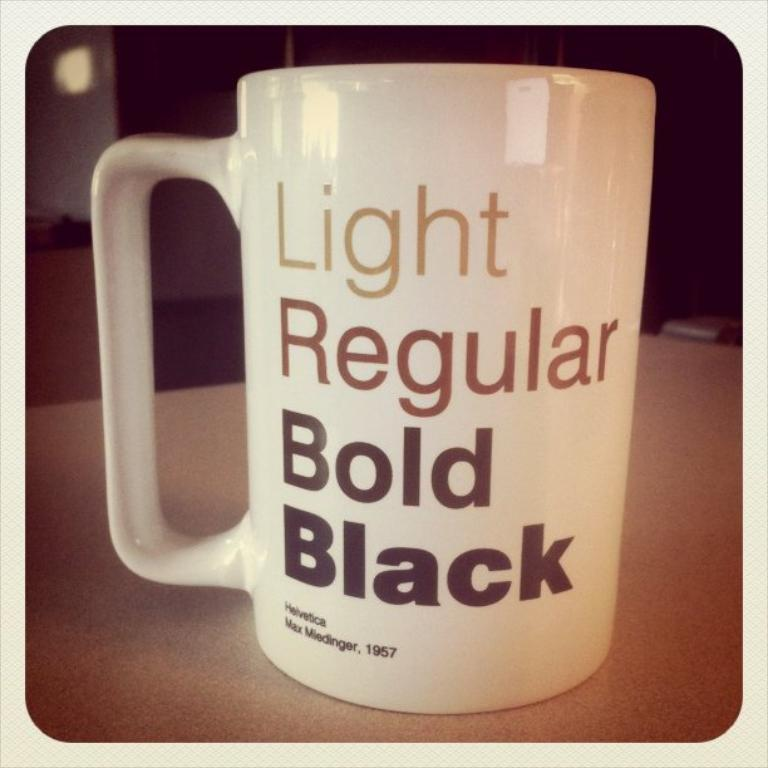<image>
Offer a succinct explanation of the picture presented. A coffee cup that has different flavors printed on it. 